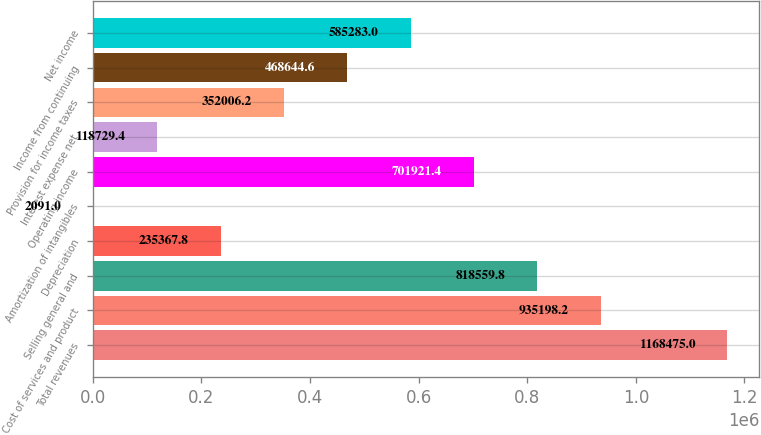<chart> <loc_0><loc_0><loc_500><loc_500><bar_chart><fcel>Total revenues<fcel>Cost of services and product<fcel>Selling general and<fcel>Depreciation<fcel>Amortization of intangibles<fcel>Operating income<fcel>Interest expense net<fcel>Provision for income taxes<fcel>Income from continuing<fcel>Net income<nl><fcel>1.16848e+06<fcel>935198<fcel>818560<fcel>235368<fcel>2091<fcel>701921<fcel>118729<fcel>352006<fcel>468645<fcel>585283<nl></chart> 